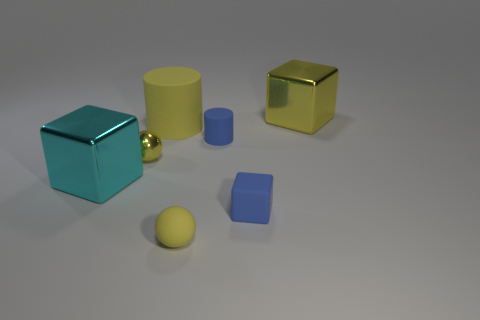Subtract all cyan blocks. How many blocks are left? 2 Subtract all cylinders. How many objects are left? 5 Add 1 tiny spheres. How many objects exist? 8 Add 6 small rubber objects. How many small rubber objects exist? 9 Subtract 0 red balls. How many objects are left? 7 Subtract all cyan metallic cylinders. Subtract all cyan cubes. How many objects are left? 6 Add 6 large rubber things. How many large rubber things are left? 7 